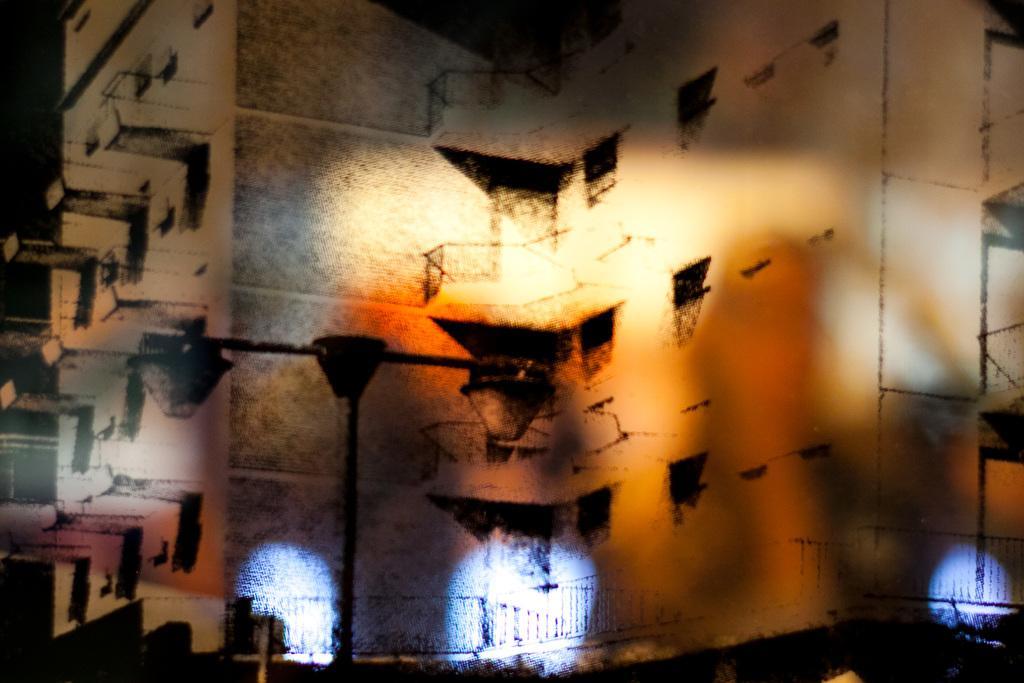Please provide a concise description of this image. In the foreground of this image, there is a pole. Behind it, there is a building. At the bottom, there are few white lights. 